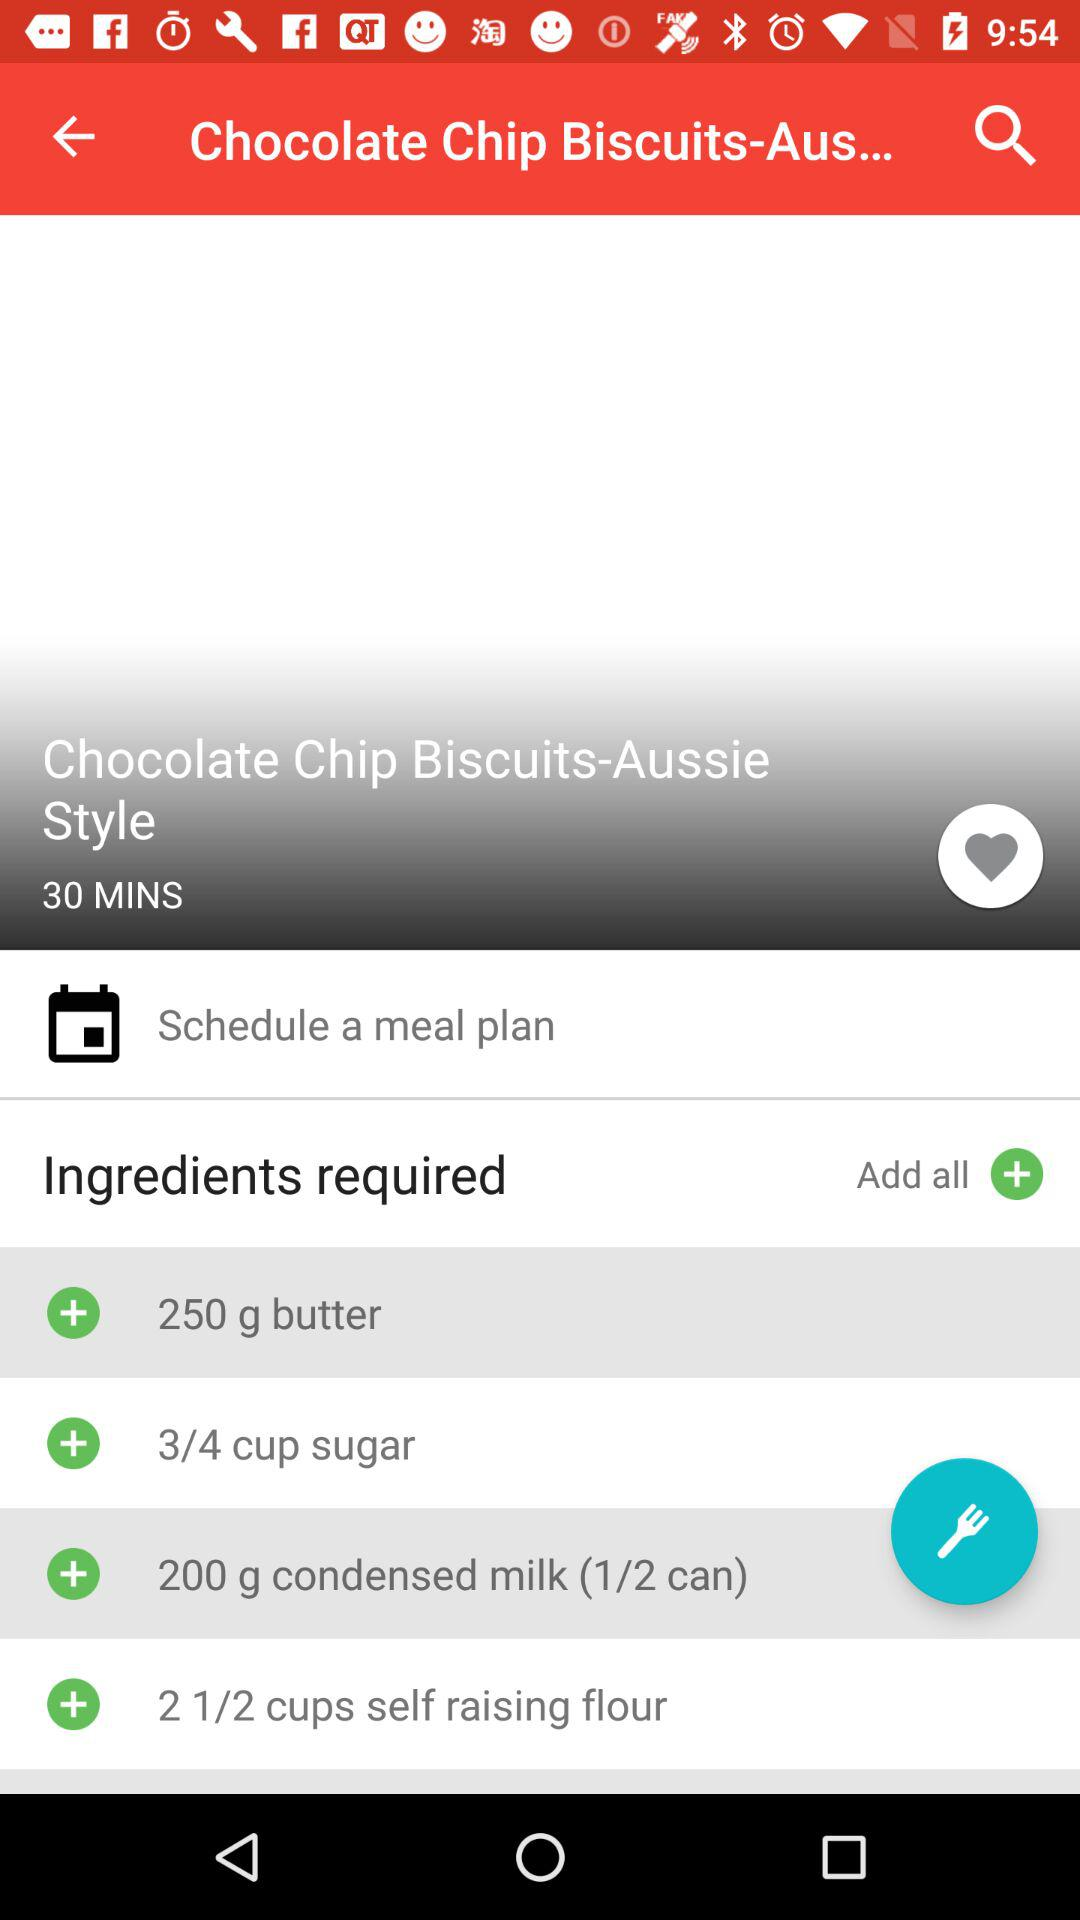How many grams of condensed milk is required? The amount of condensed milk required is 200 grams. 